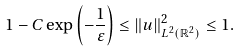<formula> <loc_0><loc_0><loc_500><loc_500>1 - C \exp \left ( - \frac { 1 } { \varepsilon } \right ) \leq \| u \| ^ { 2 } _ { L ^ { 2 } ( \mathbb { R } ^ { 2 } ) } \leq 1 .</formula> 